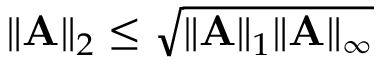Convert formula to latex. <formula><loc_0><loc_0><loc_500><loc_500>\| A \| _ { 2 } \leq \sqrt { \| A \| _ { 1 } \| A \| _ { \infty } }</formula> 